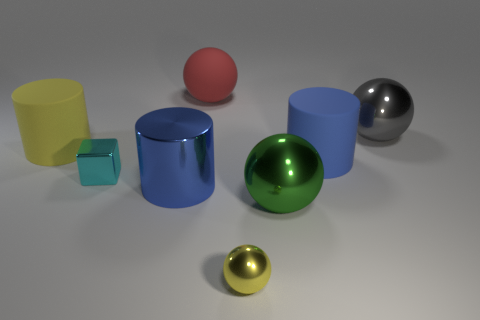How many large rubber cylinders have the same color as the tiny metal sphere?
Keep it short and to the point. 1. There is a blue thing that is on the left side of the small yellow thing; does it have the same shape as the yellow metal thing?
Ensure brevity in your answer.  No. Does the big yellow object have the same shape as the blue rubber object?
Make the answer very short. Yes. Is there a big blue rubber thing that has the same shape as the blue metallic object?
Offer a terse response. Yes. What shape is the yellow thing that is in front of the thing that is to the left of the metallic cube?
Your response must be concise. Sphere. The large matte object that is right of the small yellow sphere is what color?
Provide a succinct answer. Blue. There is a green object that is the same material as the cyan block; what is its size?
Your response must be concise. Large. There is a yellow shiny object that is the same shape as the red thing; what is its size?
Your answer should be very brief. Small. Is there a blue metallic ball?
Ensure brevity in your answer.  No. What number of objects are large blue objects that are right of the metal cylinder or small brown things?
Ensure brevity in your answer.  1. 